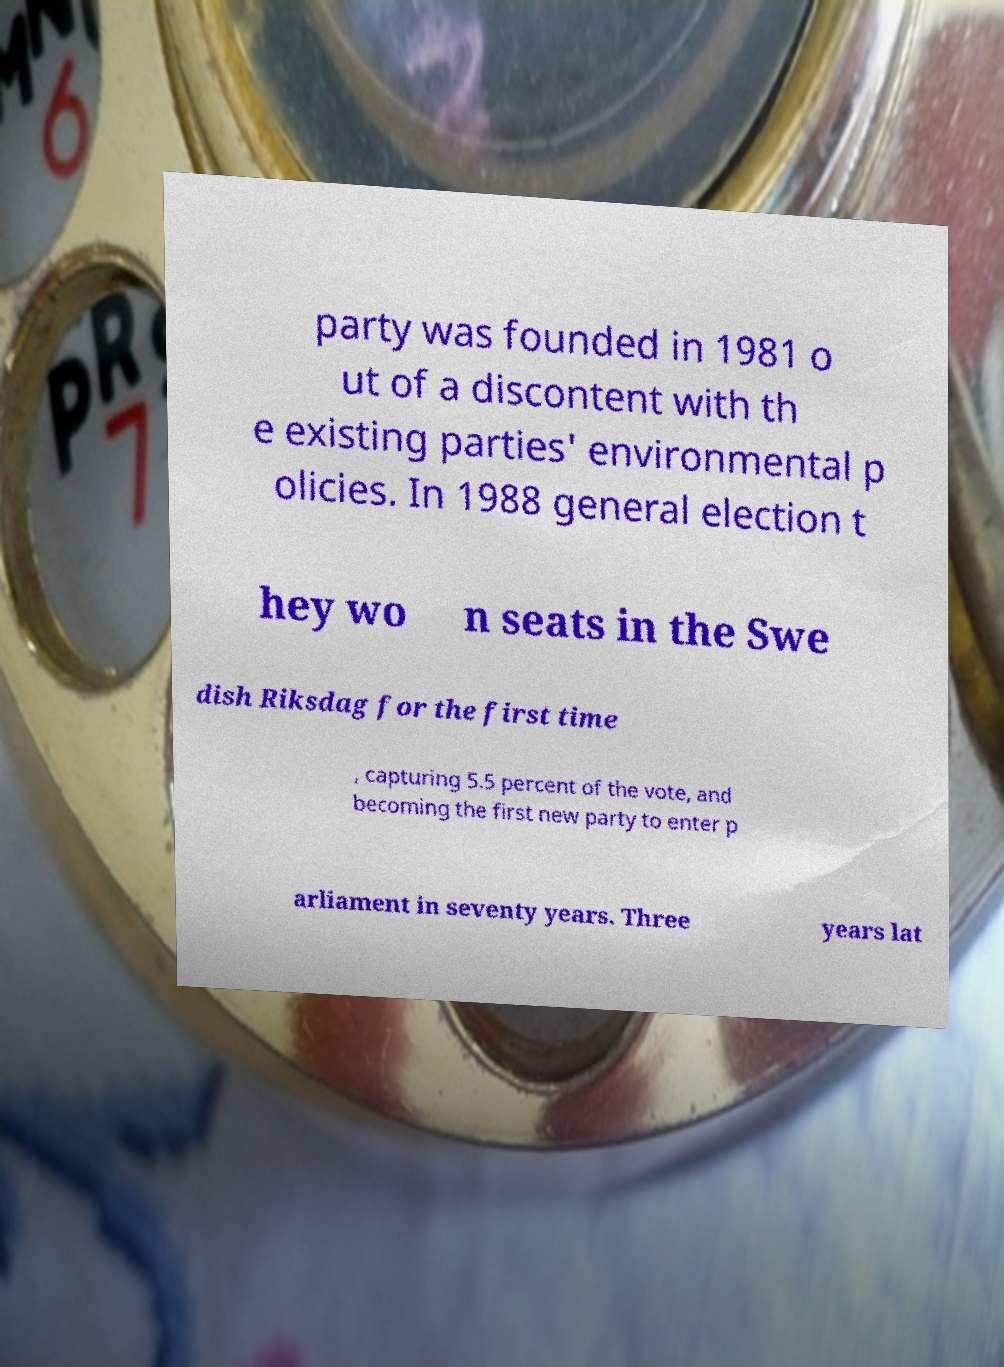I need the written content from this picture converted into text. Can you do that? party was founded in 1981 o ut of a discontent with th e existing parties' environmental p olicies. In 1988 general election t hey wo n seats in the Swe dish Riksdag for the first time , capturing 5.5 percent of the vote, and becoming the first new party to enter p arliament in seventy years. Three years lat 